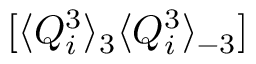Convert formula to latex. <formula><loc_0><loc_0><loc_500><loc_500>[ \langle Q _ { i } ^ { 3 } \rangle _ { 3 } \langle Q _ { i } ^ { 3 } \rangle _ { - 3 } ]</formula> 